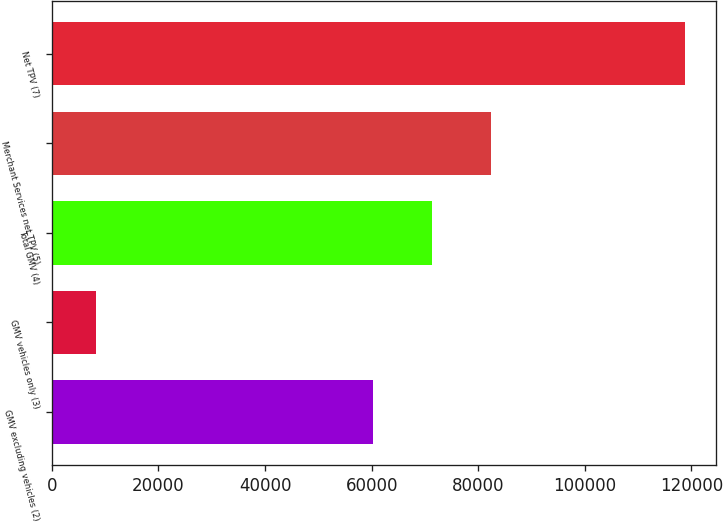<chart> <loc_0><loc_0><loc_500><loc_500><bar_chart><fcel>GMV excluding vehicles (2)<fcel>GMV vehicles only (3)<fcel>Total GMV (4)<fcel>Merchant Services net TPV (5)<fcel>Net TPV (7)<nl><fcel>60332<fcel>8301<fcel>71377.7<fcel>82423.4<fcel>118758<nl></chart> 